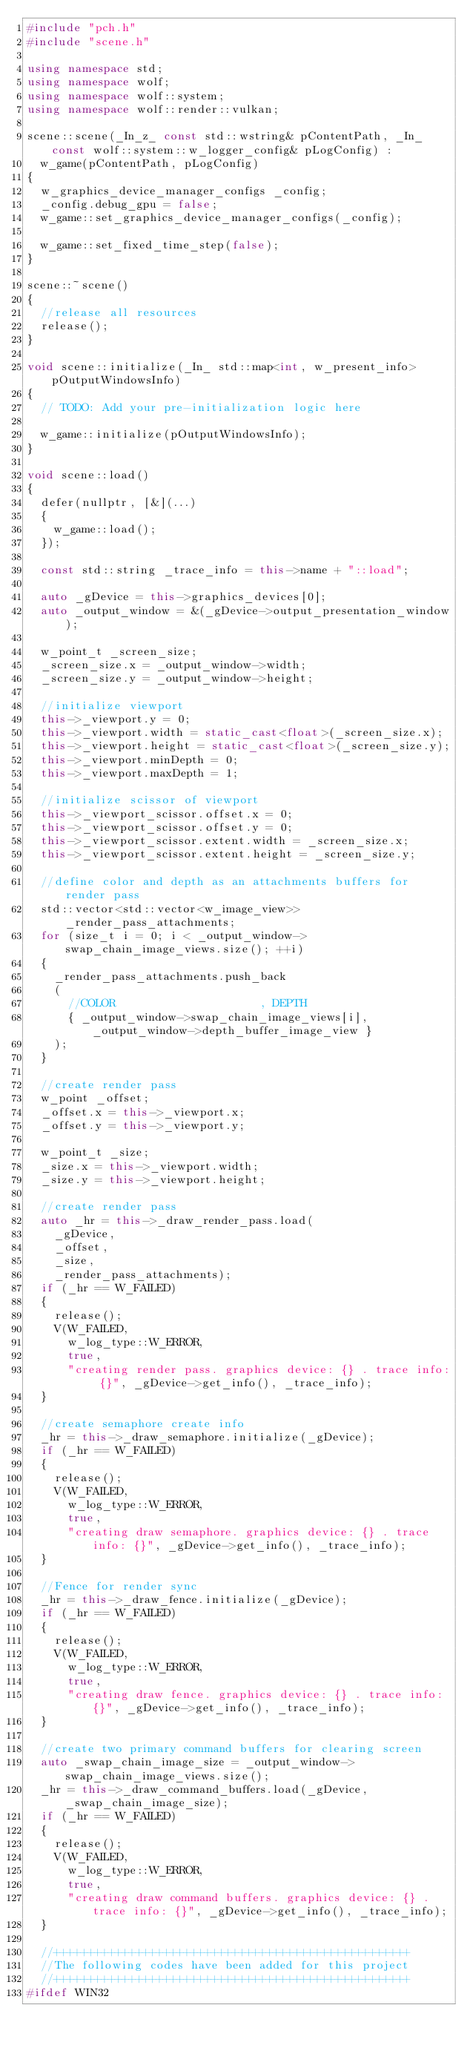<code> <loc_0><loc_0><loc_500><loc_500><_C++_>#include "pch.h"
#include "scene.h"

using namespace std;
using namespace wolf;
using namespace wolf::system;
using namespace wolf::render::vulkan;

scene::scene(_In_z_ const std::wstring& pContentPath, _In_ const wolf::system::w_logger_config& pLogConfig) :
	w_game(pContentPath, pLogConfig)
{
	w_graphics_device_manager_configs _config;
	_config.debug_gpu = false;
	w_game::set_graphics_device_manager_configs(_config);
    
	w_game::set_fixed_time_step(false);
}

scene::~scene()
{
	//release all resources
	release();
}

void scene::initialize(_In_ std::map<int, w_present_info> pOutputWindowsInfo)
{
	// TODO: Add your pre-initialization logic here

	w_game::initialize(pOutputWindowsInfo);
}

void scene::load()
{
	defer(nullptr, [&](...)
	{
		w_game::load();
	});

	const std::string _trace_info = this->name + "::load";

	auto _gDevice = this->graphics_devices[0];
	auto _output_window = &(_gDevice->output_presentation_window);

	w_point_t _screen_size;
	_screen_size.x = _output_window->width;
	_screen_size.y = _output_window->height;

	//initialize viewport
	this->_viewport.y = 0;
	this->_viewport.width = static_cast<float>(_screen_size.x);
	this->_viewport.height = static_cast<float>(_screen_size.y);
	this->_viewport.minDepth = 0;
	this->_viewport.maxDepth = 1;

	//initialize scissor of viewport
	this->_viewport_scissor.offset.x = 0;
	this->_viewport_scissor.offset.y = 0;
	this->_viewport_scissor.extent.width = _screen_size.x;
	this->_viewport_scissor.extent.height = _screen_size.y;

	//define color and depth as an attachments buffers for render pass
	std::vector<std::vector<w_image_view>> _render_pass_attachments;
	for (size_t i = 0; i < _output_window->swap_chain_image_views.size(); ++i)
	{
		_render_pass_attachments.push_back
		(
			//COLOR										  , DEPTH
			{ _output_window->swap_chain_image_views[i], _output_window->depth_buffer_image_view }
		);
	}

	//create render pass
	w_point _offset;
	_offset.x = this->_viewport.x;
	_offset.y = this->_viewport.y;

	w_point_t _size;
	_size.x = this->_viewport.width;
	_size.y = this->_viewport.height;

	//create render pass
	auto _hr = this->_draw_render_pass.load(
		_gDevice,
		_offset,
		_size,
		_render_pass_attachments);
	if (_hr == W_FAILED)
	{
		release();
		V(W_FAILED, 
			w_log_type::W_ERROR,
			true,
			"creating render pass. graphics device: {} . trace info: {}", _gDevice->get_info(), _trace_info);
	}

	//create semaphore create info
	_hr = this->_draw_semaphore.initialize(_gDevice);
	if (_hr == W_FAILED)
	{
		release();
		V(W_FAILED, 
			w_log_type::W_ERROR,
			true,
			"creating draw semaphore. graphics device: {} . trace info: {}", _gDevice->get_info(), _trace_info);
	}

	//Fence for render sync
	_hr = this->_draw_fence.initialize(_gDevice);
	if (_hr == W_FAILED)
	{
		release();
		V(W_FAILED, 
			w_log_type::W_ERROR,
			true,
			"creating draw fence. graphics device: {} . trace info: {}", _gDevice->get_info(), _trace_info);
	}

	//create two primary command buffers for clearing screen
	auto _swap_chain_image_size = _output_window->swap_chain_image_views.size();
	_hr = this->_draw_command_buffers.load(_gDevice, _swap_chain_image_size);
	if (_hr == W_FAILED)
	{
		release();
		V(W_FAILED, 
			w_log_type::W_ERROR,
			true,
			"creating draw command buffers. graphics device: {} . trace info: {}", _gDevice->get_info(), _trace_info);
	}

	//++++++++++++++++++++++++++++++++++++++++++++++++++++
	//The following codes have been added for this project
	//++++++++++++++++++++++++++++++++++++++++++++++++++++
#ifdef WIN32</code> 